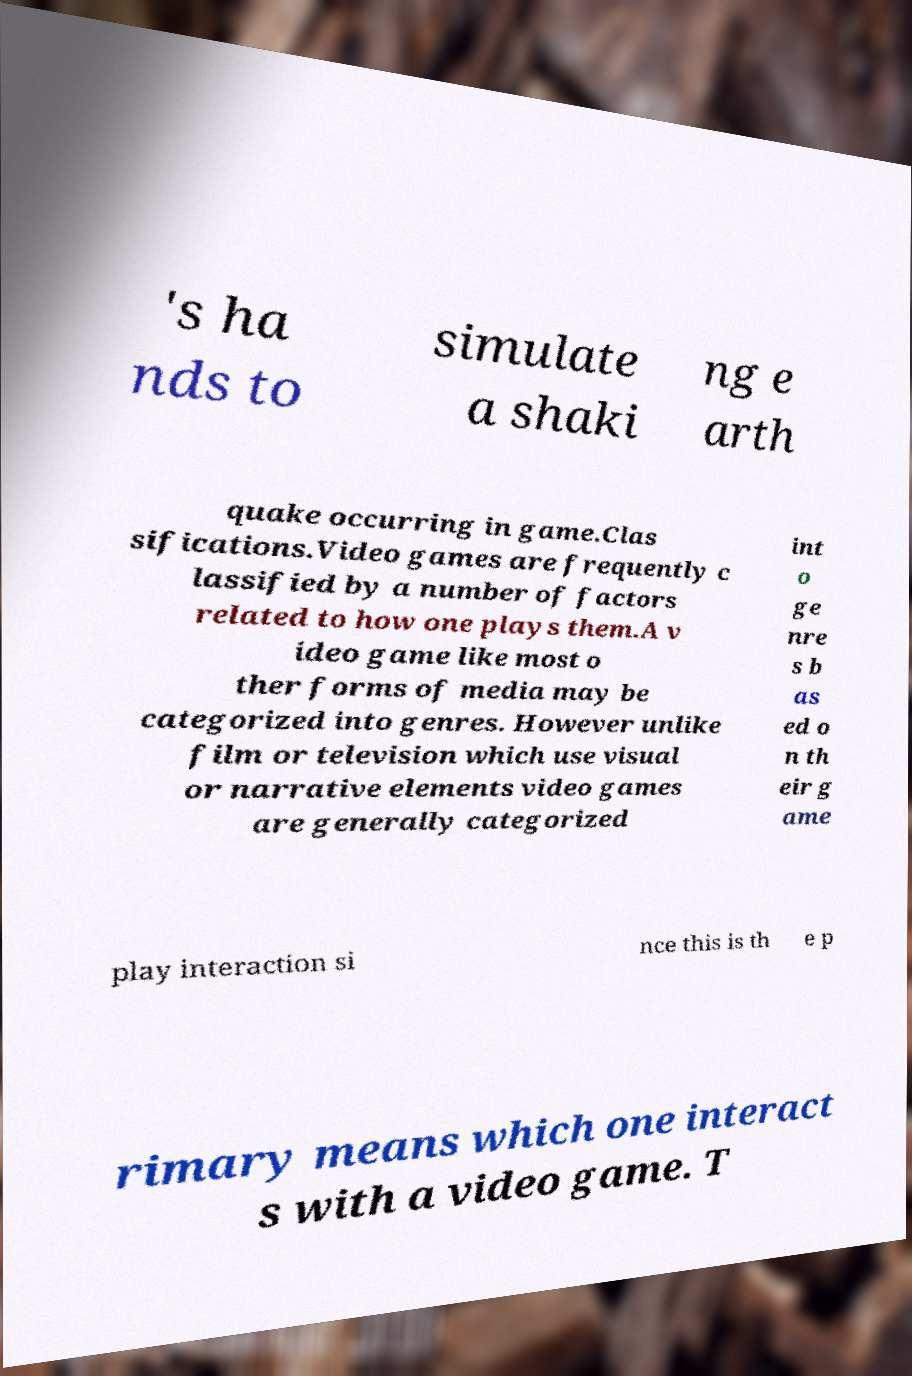Could you assist in decoding the text presented in this image and type it out clearly? 's ha nds to simulate a shaki ng e arth quake occurring in game.Clas sifications.Video games are frequently c lassified by a number of factors related to how one plays them.A v ideo game like most o ther forms of media may be categorized into genres. However unlike film or television which use visual or narrative elements video games are generally categorized int o ge nre s b as ed o n th eir g ame play interaction si nce this is th e p rimary means which one interact s with a video game. T 